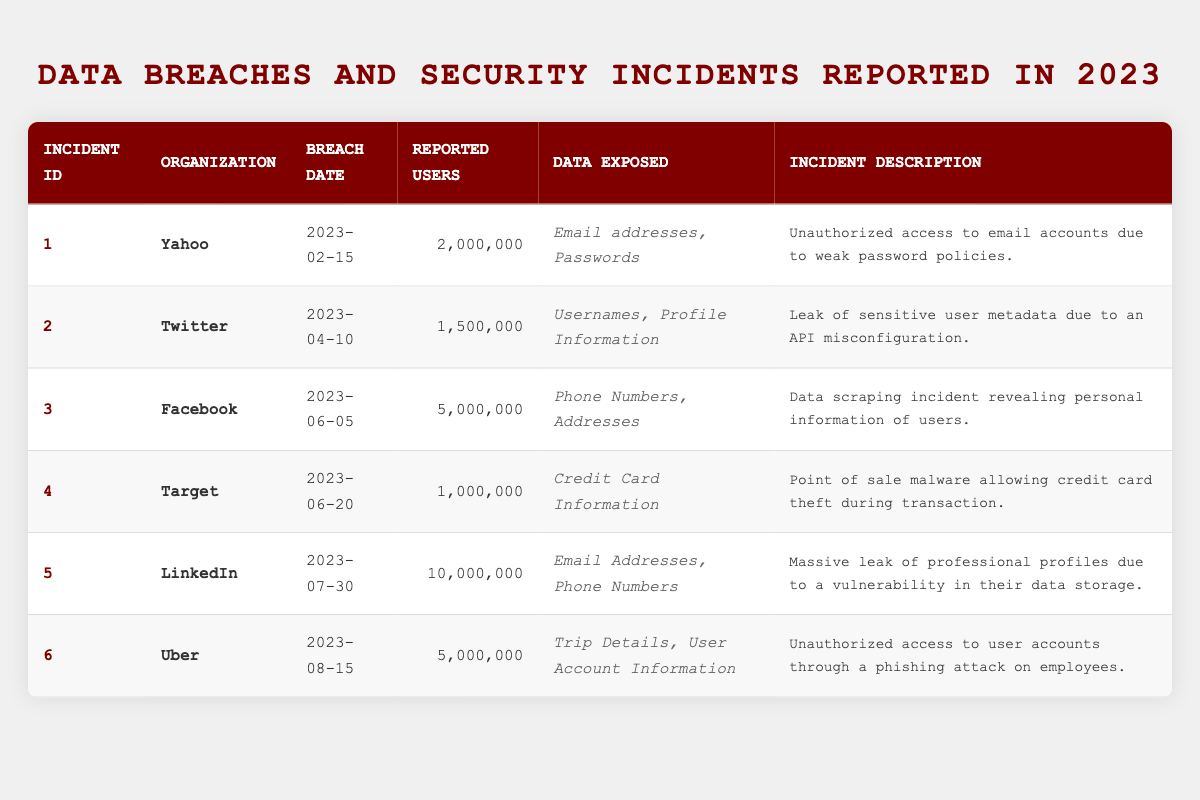What organization reported the highest number of exposed user accounts? By examining the "Reported Users" column, LinkedIn has the highest value of 10,000,000 users, compared to all other organizations listed.
Answer: LinkedIn How many total users were affected by breaches in 2023? To find the total, add the reported users for all incidents: 2,000,000 + 1,500,000 + 5,000,000 + 1,000,000 + 10,000,000 + 5,000,000 = 24,500,000.
Answer: 24,500,000 Was any organization reported to have experienced a breach before June 2023? Yes, both Yahoo and Twitter had breaches reported before June. Yahoo's breach was on February 15, and Twitter's was on April 10.
Answer: Yes What kind of data was exposed in the incident involving Target? The table indicates that Target exposed credit card information during its breach.
Answer: Credit Card Information Which company suffered a breach due to a phishing attack? According to the table, Uber suffered a breach through a phishing attack on employees, as noted in the incident description.
Answer: Uber Which organization had fewer than 2 million reported users affected? Only Target had 1,000,000 reported users affected, which is fewer than 2 million.
Answer: Target What was the incident date for Facebook's data breach? The table indicates that Facebook's data breach occurred on June 5, 2023.
Answer: June 5, 2023 How many organizations exposed email addresses in their incidents? Analyzing the data exposure, Yahoo and LinkedIn exposed email addresses. Therefore, there are two organizations.
Answer: 2 If we identify the incident with the most reported users and the one with the least, what is the difference in reported users between them? The highest reported users were from LinkedIn (10,000,000) and the least from Target (1,000,000). The difference is 10,000,000 - 1,000,000 = 9,000,000.
Answer: 9,000,000 Is the incident description for the breach involving Twitter related to configuration issues? Yes, the description states it was caused by an API misconfiguration, which indicates a configuration issue.
Answer: Yes What was the most common type of data exposed across all incidents listed? By reviewing the "Data Exposed" column, both email addresses and personal information (like phone numbers) appear multiple times across different breaches; however, email addresses are mentioned in two incidents.
Answer: Email Addresses 